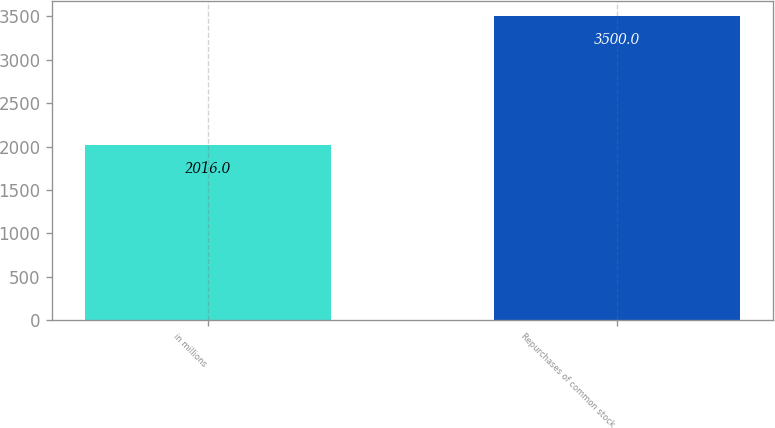Convert chart. <chart><loc_0><loc_0><loc_500><loc_500><bar_chart><fcel>in millions<fcel>Repurchases of common stock<nl><fcel>2016<fcel>3500<nl></chart> 